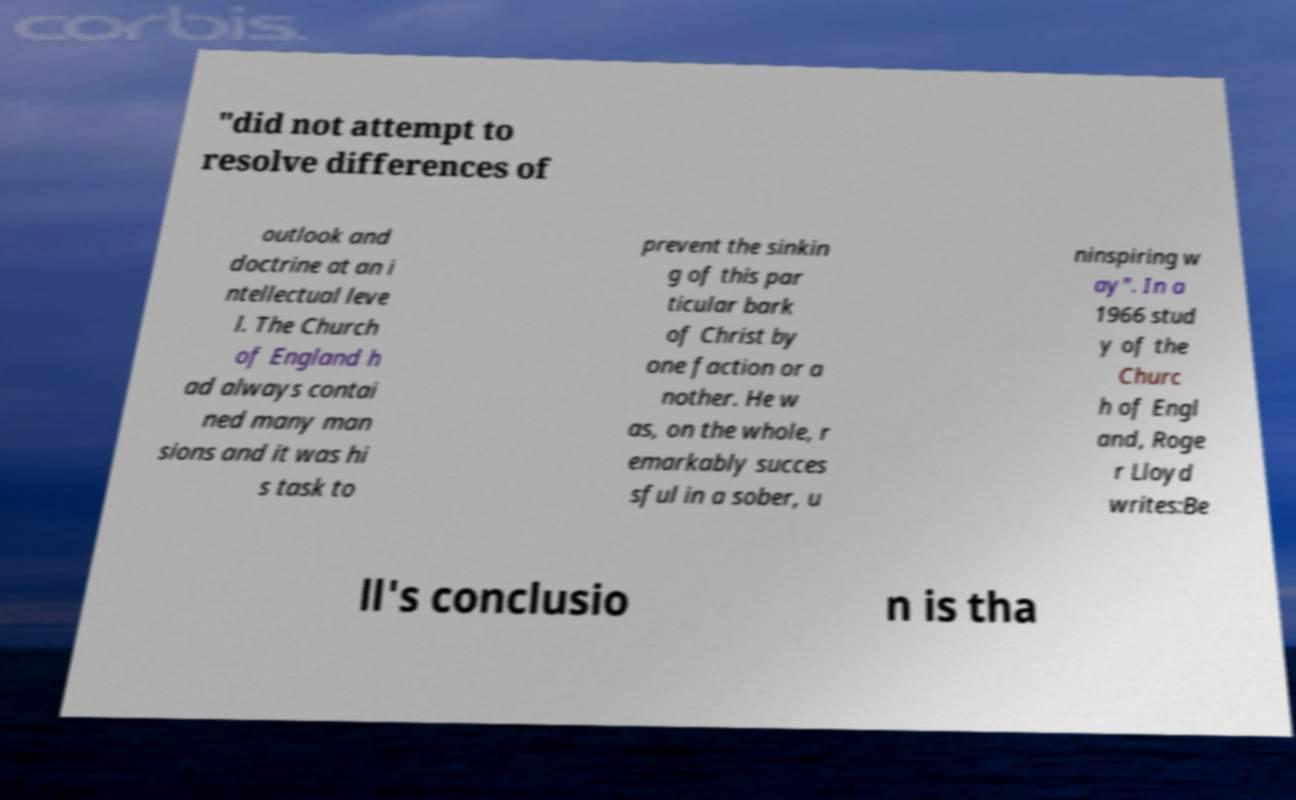Could you assist in decoding the text presented in this image and type it out clearly? "did not attempt to resolve differences of outlook and doctrine at an i ntellectual leve l. The Church of England h ad always contai ned many man sions and it was hi s task to prevent the sinkin g of this par ticular bark of Christ by one faction or a nother. He w as, on the whole, r emarkably succes sful in a sober, u ninspiring w ay". In a 1966 stud y of the Churc h of Engl and, Roge r Lloyd writes:Be ll's conclusio n is tha 